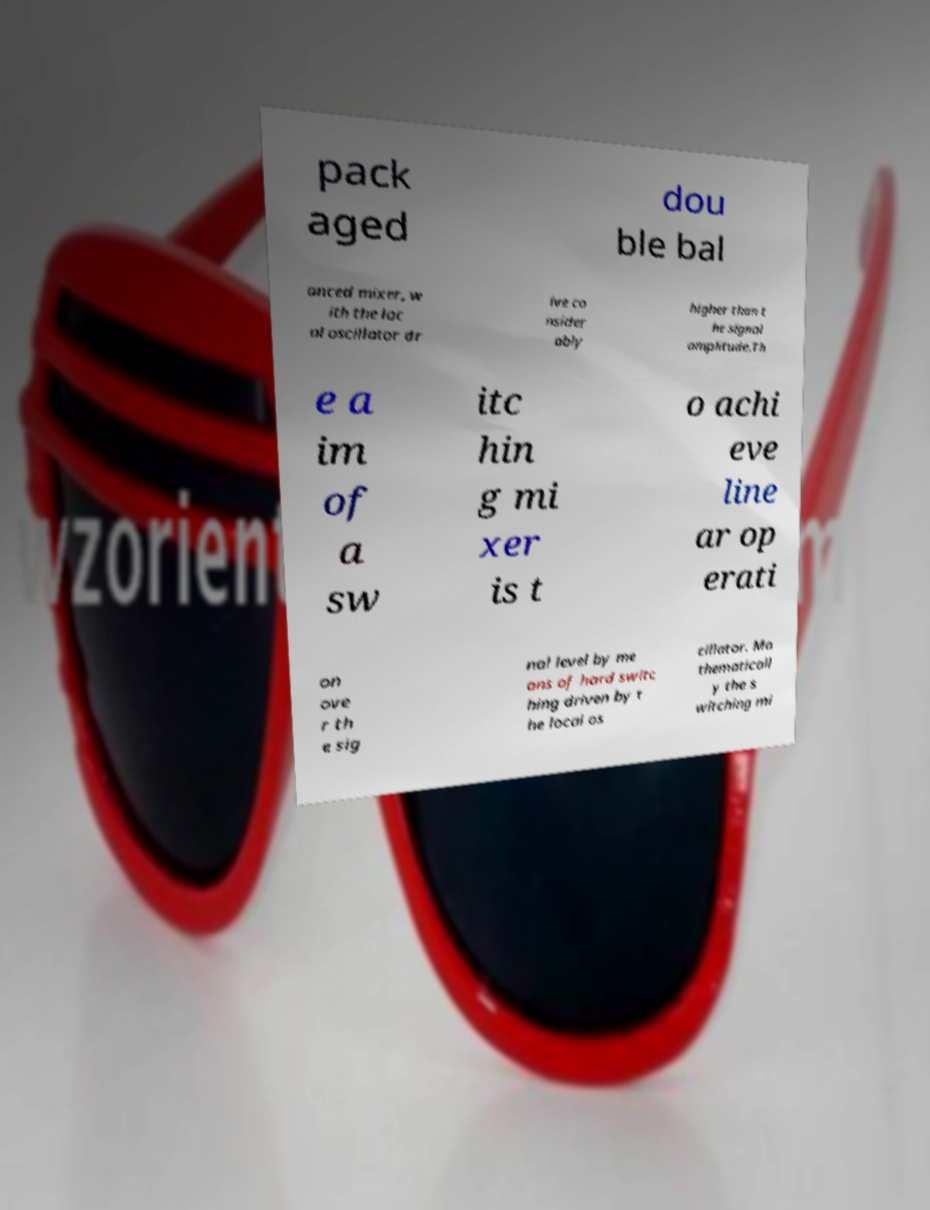Could you assist in decoding the text presented in this image and type it out clearly? pack aged dou ble bal anced mixer, w ith the loc al oscillator dr ive co nsider ably higher than t he signal amplitude.Th e a im of a sw itc hin g mi xer is t o achi eve line ar op erati on ove r th e sig nal level by me ans of hard switc hing driven by t he local os cillator. Ma thematicall y the s witching mi 